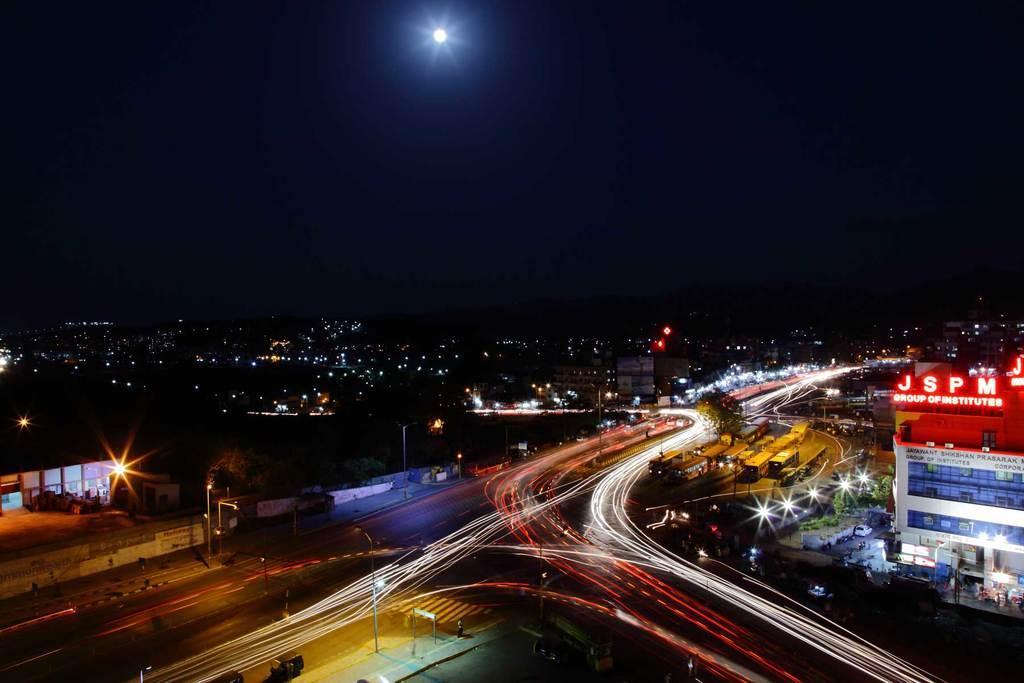Describe this image in one or two sentences. This image is an aerial view. At the bottom of the image there are roads and we can see vehicles on the roads. There are poles and we can see lights. In the background there are buildings and stores. At the top there is sky. 